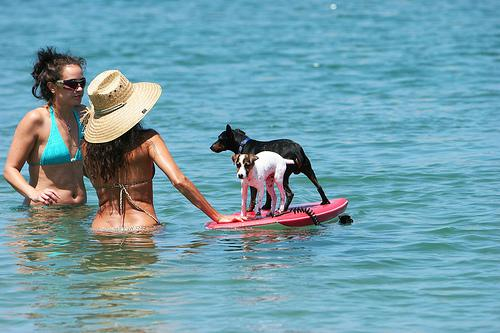Question: what color is the board?
Choices:
A. White.
B. Blue.
C. Red.
D. Pink.
Answer with the letter. Answer: C Question: where was this picture taken?
Choices:
A. On an ocean.
B. On a river.
C. On a pond.
D. On a lake.
Answer with the letter. Answer: D Question: what are the dogs standing on?
Choices:
A. The grass.
B. A bed.
C. A car.
D. A board.
Answer with the letter. Answer: D Question: how many dinosaurs are in the picture?
Choices:
A. Eight.
B. Ten.
C. Eleven.
D. Zero.
Answer with the letter. Answer: D Question: how many elephants are pictured?
Choices:
A. Two.
B. Three.
C. Zero.
D. Four.
Answer with the letter. Answer: C 